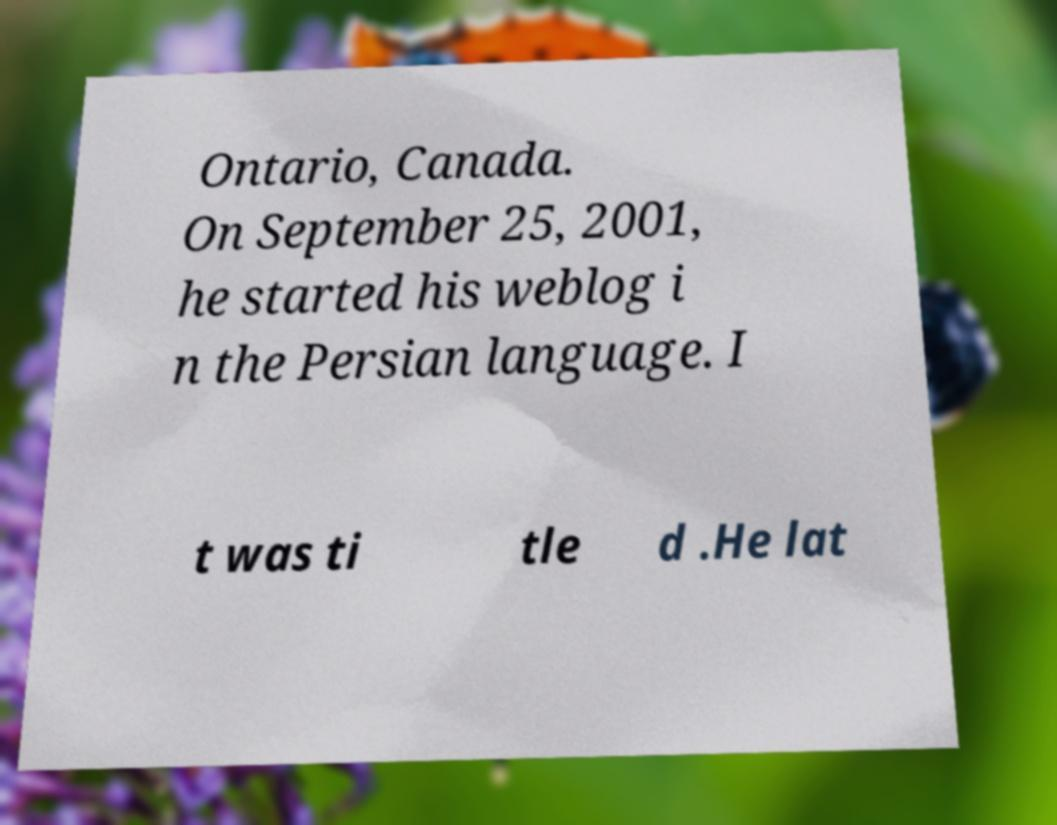Can you accurately transcribe the text from the provided image for me? Ontario, Canada. On September 25, 2001, he started his weblog i n the Persian language. I t was ti tle d .He lat 